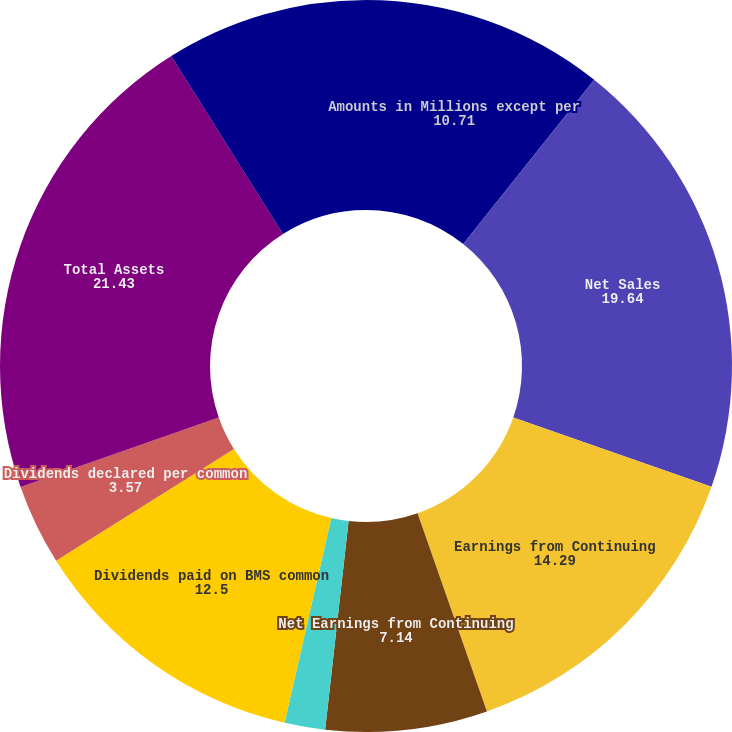Convert chart to OTSL. <chart><loc_0><loc_0><loc_500><loc_500><pie_chart><fcel>Amounts in Millions except per<fcel>Net Sales<fcel>Earnings from Continuing<fcel>Net Earnings from Continuing<fcel>Basic<fcel>Diluted<fcel>Dividends paid on BMS common<fcel>Dividends declared per common<fcel>Total Assets<fcel>Cash and cash equivalents<nl><fcel>10.71%<fcel>19.64%<fcel>14.29%<fcel>7.14%<fcel>0.0%<fcel>1.79%<fcel>12.5%<fcel>3.57%<fcel>21.43%<fcel>8.93%<nl></chart> 